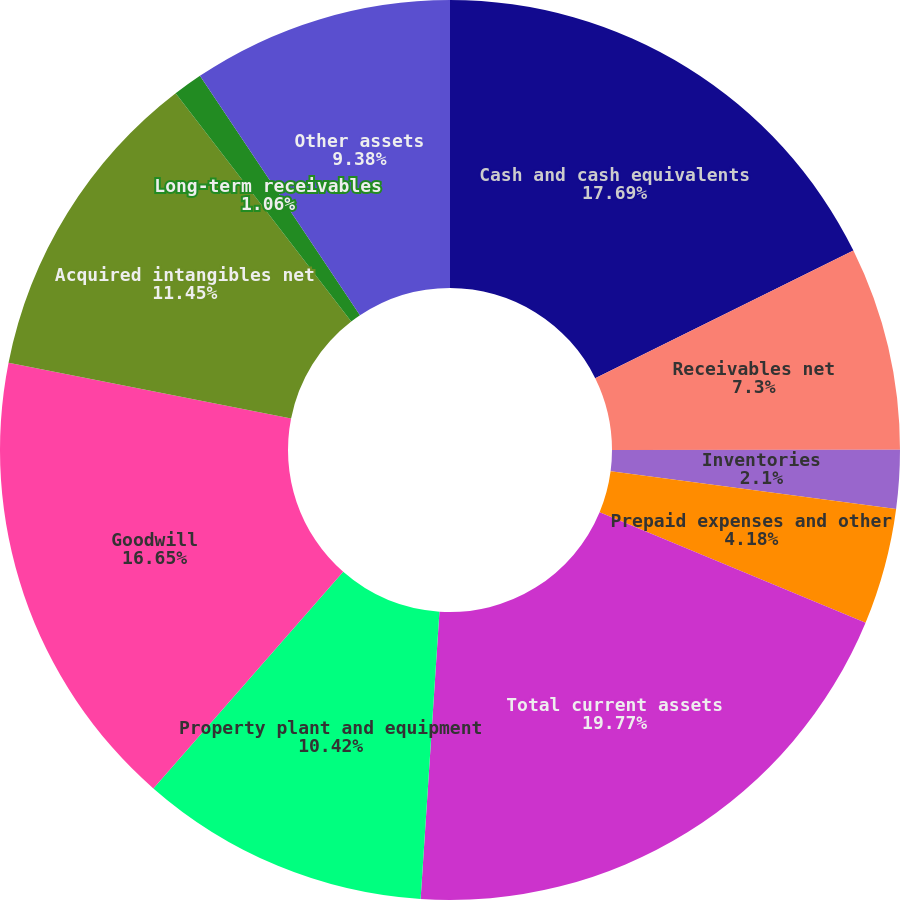Convert chart. <chart><loc_0><loc_0><loc_500><loc_500><pie_chart><fcel>Cash and cash equivalents<fcel>Receivables net<fcel>Inventories<fcel>Prepaid expenses and other<fcel>Total current assets<fcel>Property plant and equipment<fcel>Goodwill<fcel>Acquired intangibles net<fcel>Long-term receivables<fcel>Other assets<nl><fcel>17.7%<fcel>7.3%<fcel>2.1%<fcel>4.18%<fcel>19.78%<fcel>10.42%<fcel>16.66%<fcel>11.46%<fcel>1.06%<fcel>9.38%<nl></chart> 